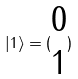Convert formula to latex. <formula><loc_0><loc_0><loc_500><loc_500>| 1 \rangle = ( \begin{matrix} 0 \\ 1 \end{matrix} )</formula> 